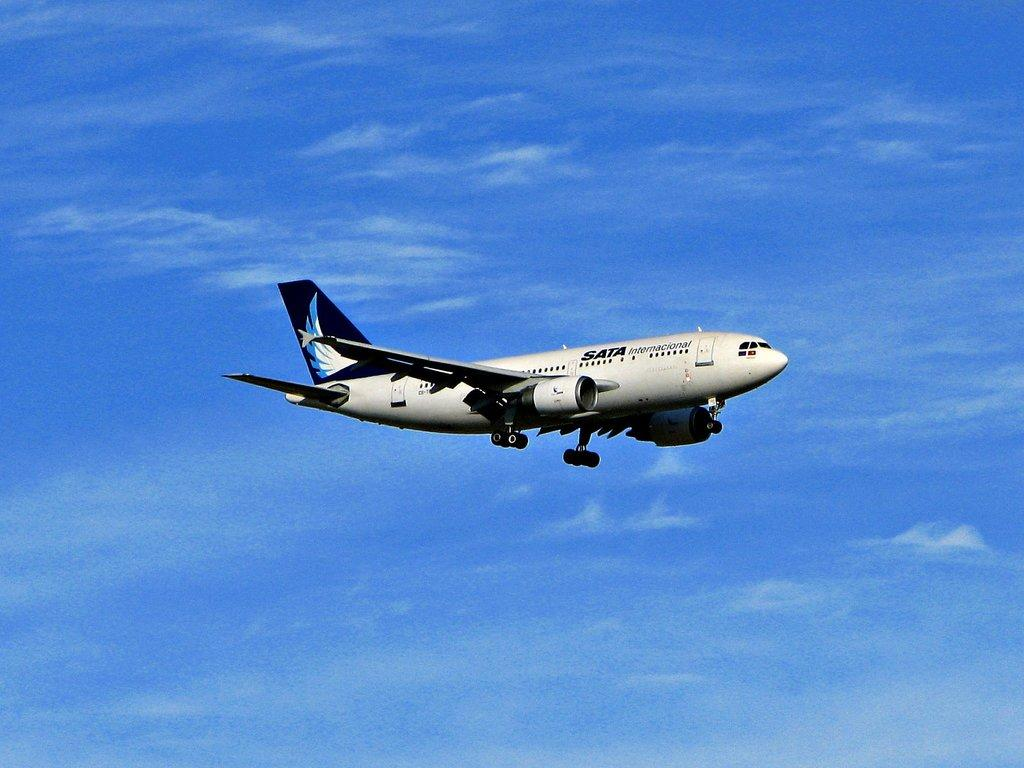What is the main subject of the picture? The main subject of the picture is an airplane. What is the color of the airplane? The airplane is white in color. What is the airplane doing in the picture? The airplane is flying in the sky. What can be seen in the background of the image? The sky is visible in the background of the image. What is the color of the sky in the image? The sky is blue in color. How many frogs are sitting on the spade in the image? There are no frogs or spades present in the image; it features an airplane flying in the sky. What is the plot of the story depicted in the image? There is no story depicted in the image, as it is a photograph of an airplane flying in the sky. 